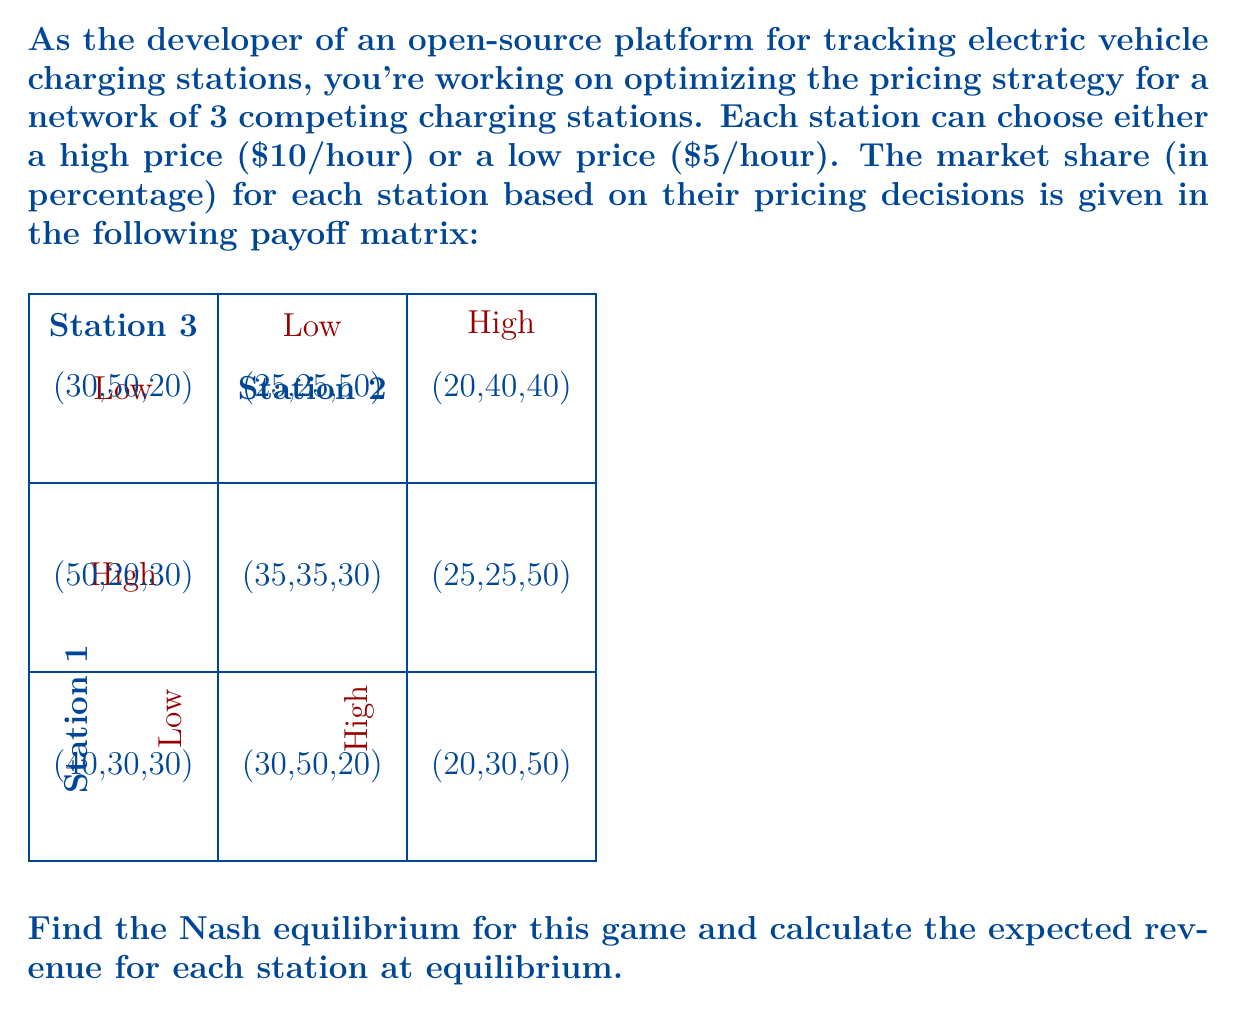Teach me how to tackle this problem. To solve this problem, we need to follow these steps:

1) Identify the best responses for each station given the other stations' strategies.
2) Find the Nash equilibrium where no station can unilaterally improve its payoff.
3) Calculate the expected revenue at equilibrium.

Step 1: Identify best responses

For Station 1:
- If 2 & 3 both choose Low: 40 > 30, so Station 1 chooses Low
- If 2 Low, 3 High: 50 > 30, so Station 1 chooses Low
- If 2 High, 3 Low: 30 > 20, so Station 1 chooses Low
- If 2 & 3 both choose High: 25 > 20, so Station 1 chooses Low

For Station 2:
- If 1 Low, 3 Low: 30 < 50, so Station 2 chooses High
- If 1 Low, 3 High: 50 > 30, so Station 2 chooses Low
- If 1 High, 3 Low: 50 > 35, so Station 2 chooses Low
- If 1 High, 3 High: 25 = 25, so Station 2 is indifferent

For Station 3:
- If 1 Low, 2 Low: 30 = 30, so Station 3 is indifferent
- If 1 Low, 2 High: 20 < 50, so Station 3 chooses High
- If 1 High, 2 Low: 20 < 50, so Station 3 chooses High
- If 1 High, 2 High: 50 > 40, so Station 3 chooses High

Step 2: Find Nash equilibrium

From the best responses, we can see that the Nash equilibrium is (Low, Low, High). At this point, no station can unilaterally improve its payoff by changing its strategy.

Step 3: Calculate expected revenue

At equilibrium (Low, Low, High), the market shares are (30%, 50%, 20%).

Revenue calculation:
- Station 1: 30% * $5/hour = $1.50/hour
- Station 2: 50% * $5/hour = $2.50/hour
- Station 3: 20% * $10/hour = $2.00/hour
Answer: Nash equilibrium: (Low, Low, High). Expected revenues: Station 1: $1.50/hour, Station 2: $2.50/hour, Station 3: $2.00/hour. 